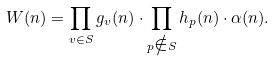<formula> <loc_0><loc_0><loc_500><loc_500>W ( n ) = \prod _ { v \in S } g _ { v } ( n ) \cdot \prod _ { p \notin S } h _ { p } ( n ) \cdot \alpha ( n ) .</formula> 